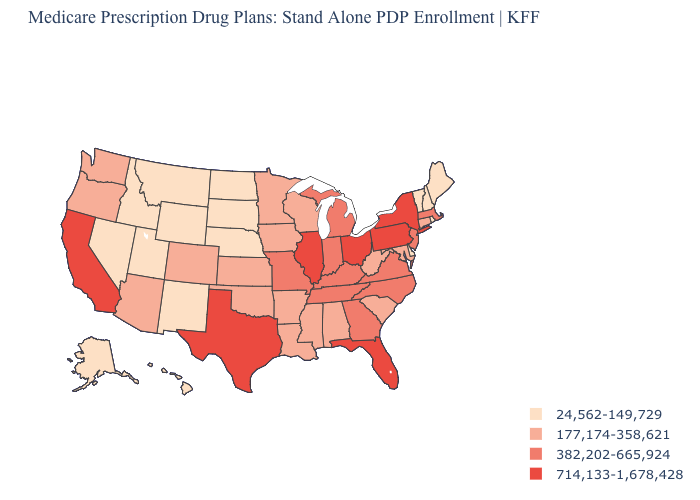What is the lowest value in the Northeast?
Be succinct. 24,562-149,729. What is the value of Nebraska?
Keep it brief. 24,562-149,729. What is the value of Colorado?
Give a very brief answer. 177,174-358,621. What is the lowest value in the USA?
Short answer required. 24,562-149,729. What is the highest value in the West ?
Give a very brief answer. 714,133-1,678,428. What is the value of Idaho?
Answer briefly. 24,562-149,729. Which states have the lowest value in the USA?
Short answer required. Alaska, Delaware, Hawaii, Idaho, Maine, Montana, North Dakota, Nebraska, New Hampshire, New Mexico, Nevada, Rhode Island, South Dakota, Utah, Vermont, Wyoming. What is the highest value in the USA?
Be succinct. 714,133-1,678,428. Does Alaska have a lower value than Washington?
Short answer required. Yes. Name the states that have a value in the range 177,174-358,621?
Short answer required. Alabama, Arkansas, Arizona, Colorado, Connecticut, Iowa, Kansas, Louisiana, Maryland, Minnesota, Mississippi, Oklahoma, Oregon, South Carolina, Washington, Wisconsin, West Virginia. What is the value of Arizona?
Write a very short answer. 177,174-358,621. Name the states that have a value in the range 24,562-149,729?
Write a very short answer. Alaska, Delaware, Hawaii, Idaho, Maine, Montana, North Dakota, Nebraska, New Hampshire, New Mexico, Nevada, Rhode Island, South Dakota, Utah, Vermont, Wyoming. Name the states that have a value in the range 382,202-665,924?
Quick response, please. Georgia, Indiana, Kentucky, Massachusetts, Michigan, Missouri, North Carolina, New Jersey, Tennessee, Virginia. What is the highest value in states that border South Carolina?
Be succinct. 382,202-665,924. Does the map have missing data?
Concise answer only. No. 